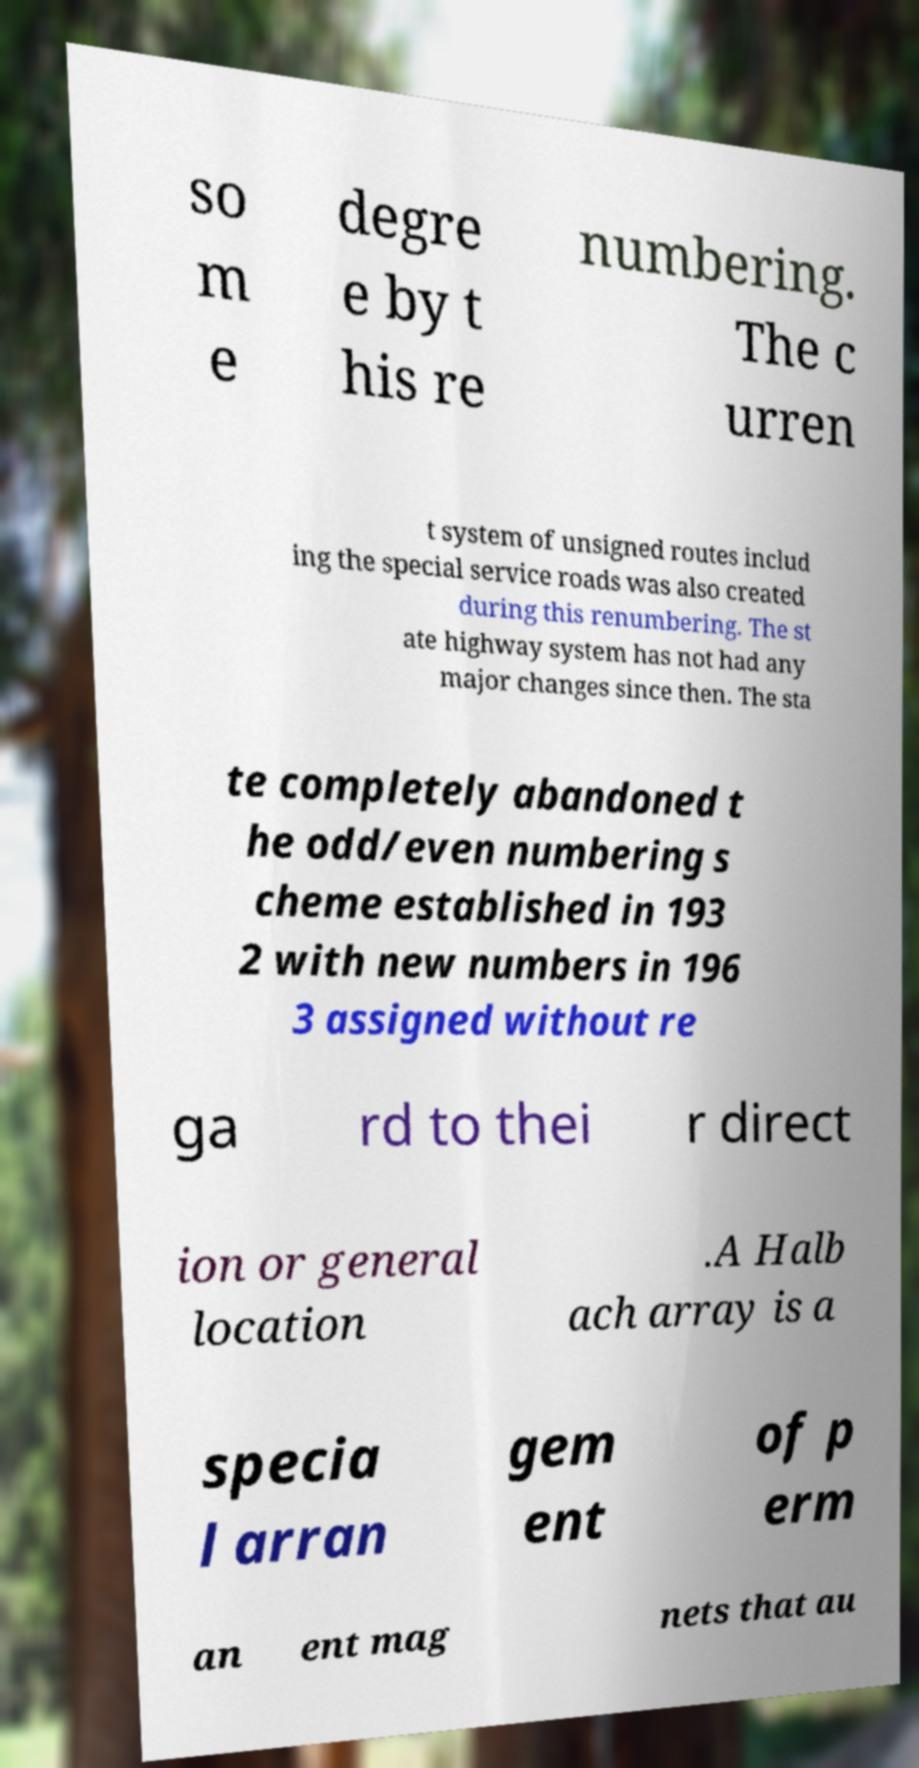Can you read and provide the text displayed in the image?This photo seems to have some interesting text. Can you extract and type it out for me? so m e degre e by t his re numbering. The c urren t system of unsigned routes includ ing the special service roads was also created during this renumbering. The st ate highway system has not had any major changes since then. The sta te completely abandoned t he odd/even numbering s cheme established in 193 2 with new numbers in 196 3 assigned without re ga rd to thei r direct ion or general location .A Halb ach array is a specia l arran gem ent of p erm an ent mag nets that au 